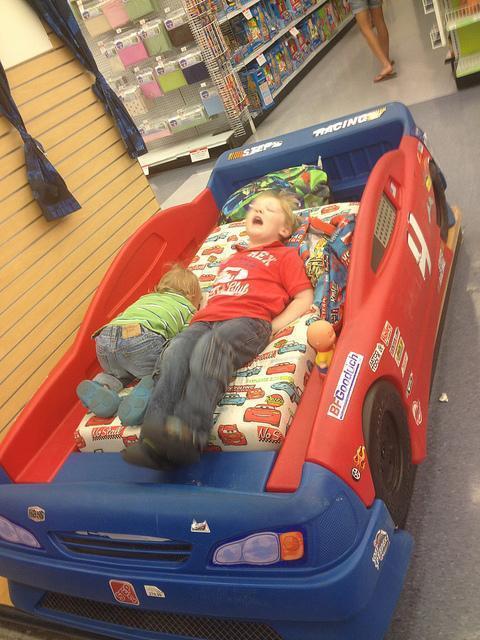How many people are in the picture?
Give a very brief answer. 2. 